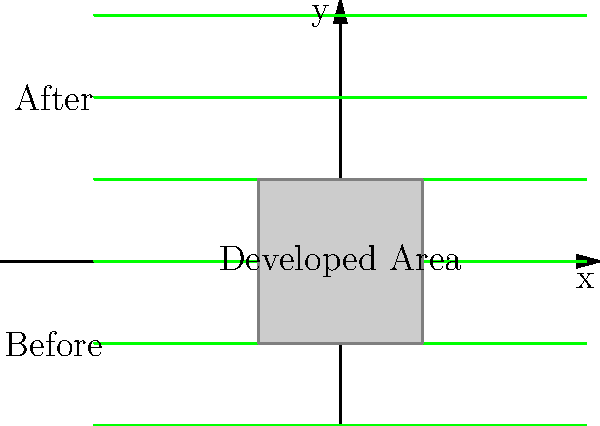Based on the before-and-after imagery of a proposed development, what percentage of the local ecosystem's green area is estimated to be lost due to the development project? To determine the percentage of green area lost due to the development project, we need to follow these steps:

1. Assess the total green area in the "Before" image:
   The "Before" image shows 3 full green lines, representing 100% of the original ecosystem.

2. Assess the remaining green area in the "After" image:
   The "After" image shows 3 full green lines above the developed area.

3. Identify the developed area:
   The gray square in the center represents the developed area, which replaces a portion of the original green area.

4. Calculate the proportion of green area lost:
   The developed area appears to cover approximately 1/3 of the original green area.

5. Convert the proportion to a percentage:
   1/3 is equivalent to approximately 33.33% of the original green area.

Therefore, the estimated percentage of the local ecosystem's green area lost due to the development project is about 33.33% or one-third of the original area.
Answer: 33.33% 